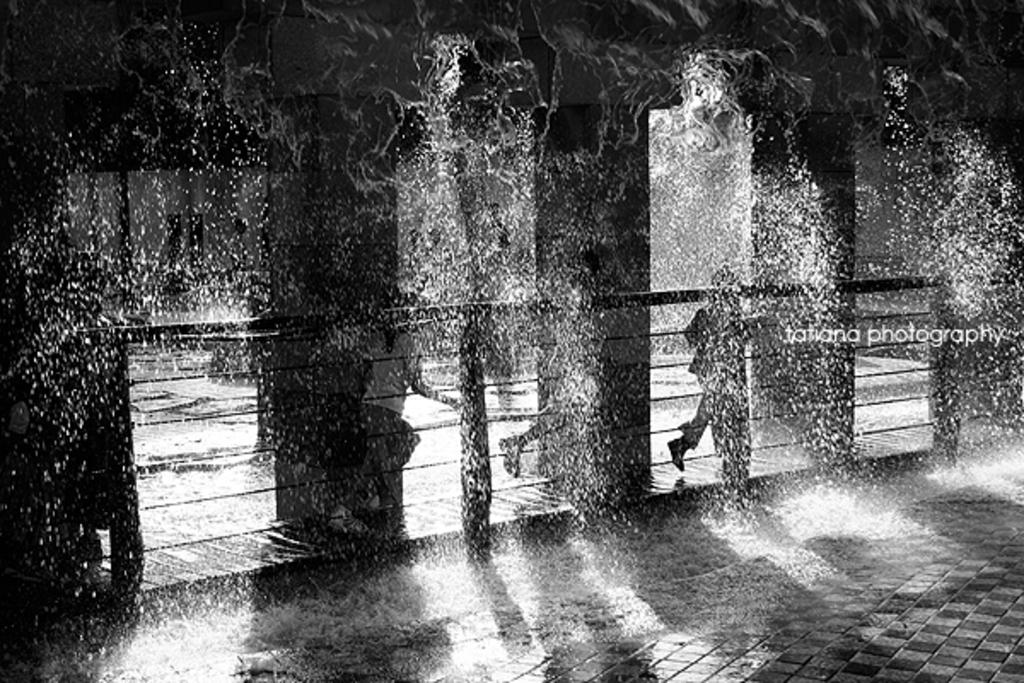What is the color scheme of the image? The image is black and white. What are the people in the image doing? The people in the image are running on a path. What is the weather like in the image? It is raining in the image. What can be seen beneath the people's feet? The floor is visible in the image. Where is the text located in the image? The text is on the right side of the image. What type of wax can be seen melting on the path in the image? There is no wax present in the image; it is raining, not melting. What kind of humor can be observed in the text on the right side of the image? There is no humor present in the image, as the text cannot be interpreted without additional context. 